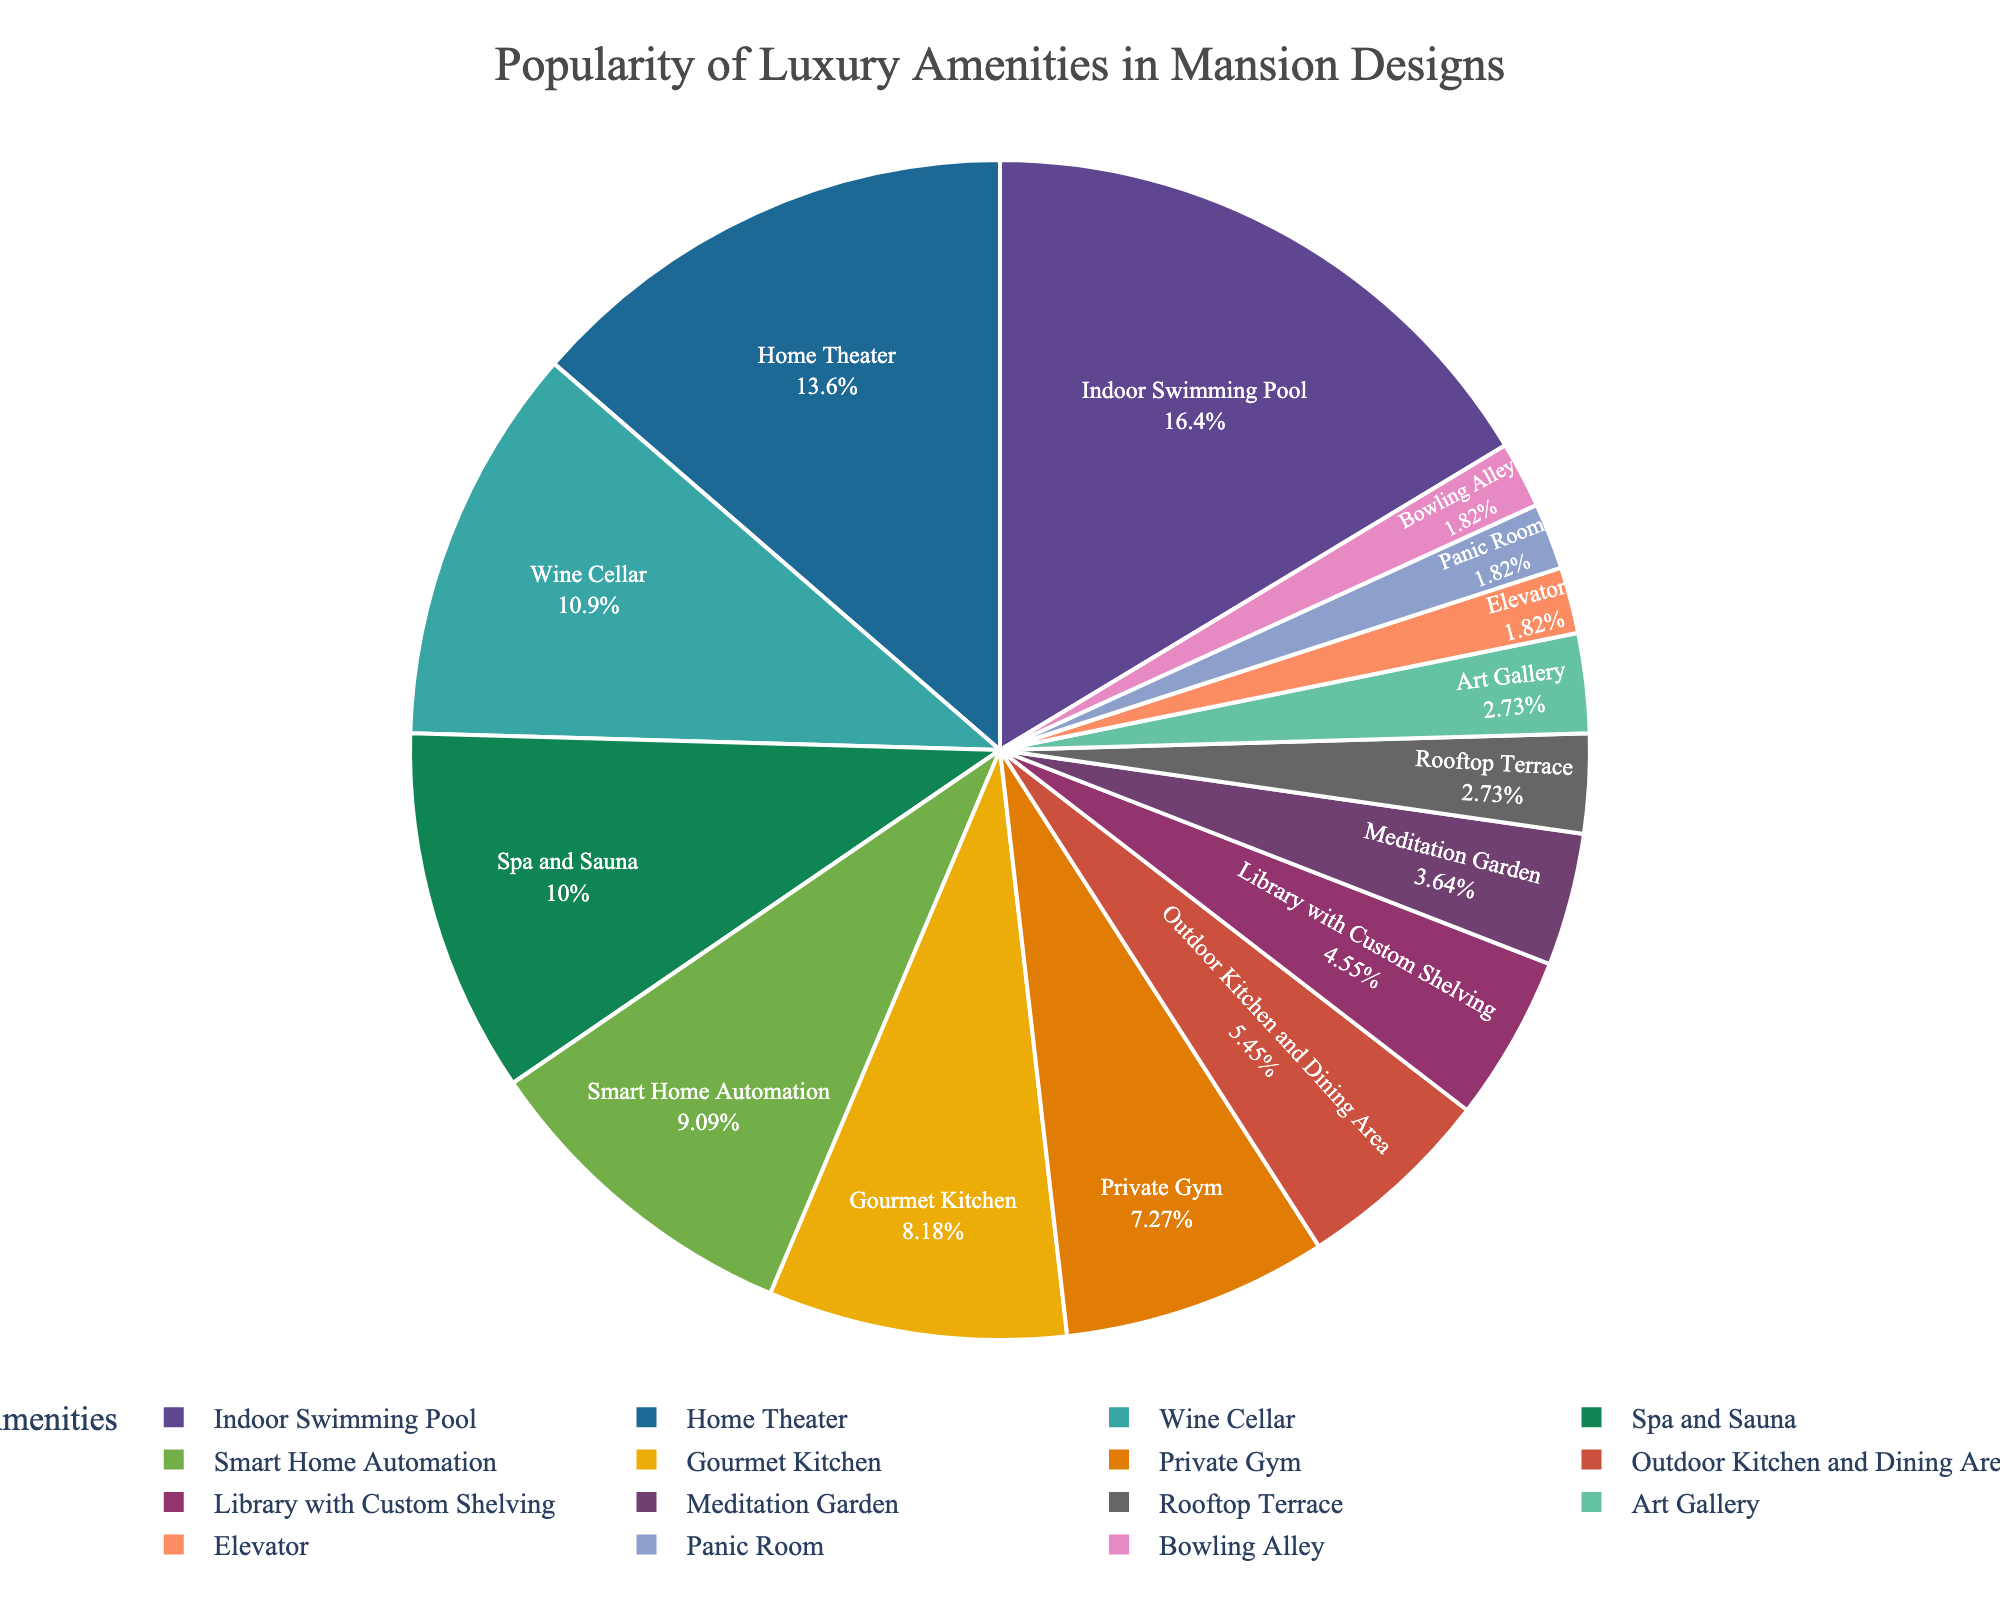Which amenity is the most popular? The figure shows that the indoor swimming pool has the highest percentage, making it the most popular amenity.
Answer: Indoor Swimming Pool What is the combined percentage of home theater and wine cellar? The data shows that the home theater is 15% and the wine cellar is 12%. Adding these two percentages together gives 15% + 12% = 27%.
Answer: 27% How does the popularity of a private gym compare to an elevator? According to the figure, the private gym has 8% whereas the elevator has 2%. Therefore, the private gym is more popular than the elevator.
Answer: Private Gym is more popular Which amenities each have 3% popularity? The figure displays that both the rooftop terrace and the art gallery each have a 3% share of popularity.
Answer: Rooftop Terrace and Art Gallery Is the percentage for spa and sauna greater than smart home automation? The figure indicates spa and sauna at 11% and smart home automation at 10%. Therefore, spa and sauna are indeed greater.
Answer: Yes Calculate the total percentage for amenities related to physical wellness (Private Gym, Spa and Sauna, Indoor Swimming Pool). The indoor swimming pool is 18%, spa and sauna are 11%, and private gym is 8%. Summing these values gives 18% + 11% + 8% = 37%.
Answer: 37% Compare the popularity of the library with custom shelving to the meditation garden. The figure shows the library with custom shelving at 5% and the meditation garden at 4%. Thus, the library with custom shelving is more popular.
Answer: Library is more popular What is the least popular amenity? The figure shows that the elevator, panic room, and bowling alley each have the lowest percentage, which is 2%.
Answer: Elevator, Panic Room, Bowling Alley By how much does the popularity of the gourmet kitchen exceed the outdoor kitchen and dining area? From the chart, the gourmet kitchen is 9% and the outdoor kitchen and dining area is 6%. The difference in popularity is 9% - 6% = 3%.
Answer: 3% Calculate the average percentage of the amenities that fall below 10% popularity. Amenities below 10%: Gourmet Kitchen (9%), Private Gym (8%), Outdoor Kitchen and Dining Area (6%), Library with Custom Shelving (5%), Meditation Garden (4%), Rooftop Terrace (3%), Art Gallery (3%), Elevator (2%), Panic Room (2%), Bowling Alley (2%). Sum = 44%. Count of amenities = 10. The average is 44% / 10 = 4.4%.
Answer: 4.4% 